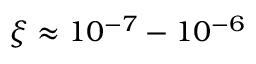<formula> <loc_0><loc_0><loc_500><loc_500>\xi \approx 1 0 ^ { - 7 } - 1 0 ^ { - 6 }</formula> 